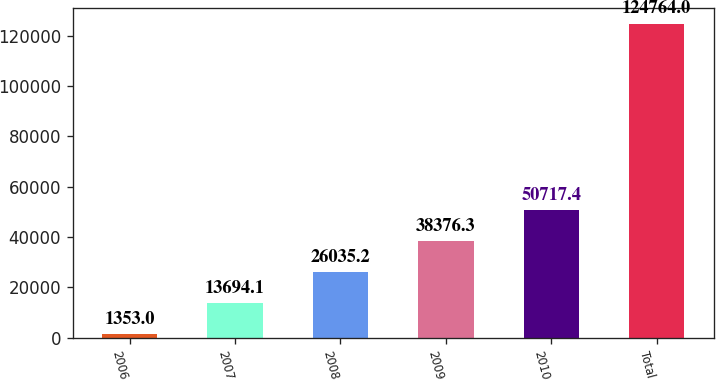Convert chart. <chart><loc_0><loc_0><loc_500><loc_500><bar_chart><fcel>2006<fcel>2007<fcel>2008<fcel>2009<fcel>2010<fcel>Total<nl><fcel>1353<fcel>13694.1<fcel>26035.2<fcel>38376.3<fcel>50717.4<fcel>124764<nl></chart> 